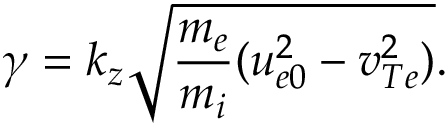Convert formula to latex. <formula><loc_0><loc_0><loc_500><loc_500>\gamma = k _ { z } \sqrt { \frac { m _ { e } } { m _ { i } } ( u _ { e 0 } ^ { 2 } - v _ { T e } ^ { 2 } ) } .</formula> 